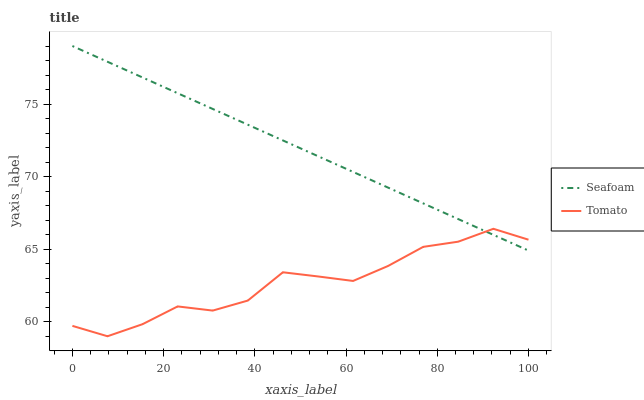Does Tomato have the minimum area under the curve?
Answer yes or no. Yes. Does Seafoam have the maximum area under the curve?
Answer yes or no. Yes. Does Seafoam have the minimum area under the curve?
Answer yes or no. No. Is Seafoam the smoothest?
Answer yes or no. Yes. Is Tomato the roughest?
Answer yes or no. Yes. Is Seafoam the roughest?
Answer yes or no. No. Does Tomato have the lowest value?
Answer yes or no. Yes. Does Seafoam have the lowest value?
Answer yes or no. No. Does Seafoam have the highest value?
Answer yes or no. Yes. Does Tomato intersect Seafoam?
Answer yes or no. Yes. Is Tomato less than Seafoam?
Answer yes or no. No. Is Tomato greater than Seafoam?
Answer yes or no. No. 